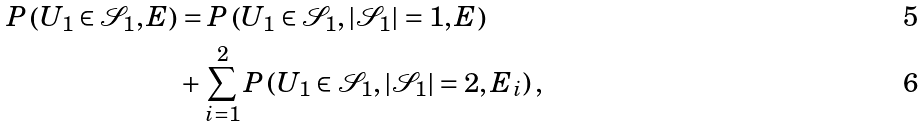<formula> <loc_0><loc_0><loc_500><loc_500>P \left ( U _ { 1 } \in \mathcal { S } _ { 1 } , E \right ) & = P \left ( U _ { 1 } \in \mathcal { S } _ { 1 } , | \mathcal { S } _ { 1 } | = 1 , E \right ) \\ & + \sum ^ { 2 } _ { i = 1 } P \left ( U _ { 1 } \in \mathcal { S } _ { 1 } , | \mathcal { S } _ { 1 } | = 2 , E _ { i } \right ) ,</formula> 